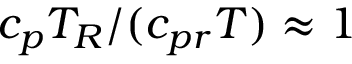<formula> <loc_0><loc_0><loc_500><loc_500>c _ { p } T _ { R } / ( c _ { p r } T ) \approx 1</formula> 